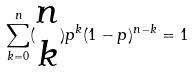<formula> <loc_0><loc_0><loc_500><loc_500>\sum _ { k = 0 } ^ { n } ( \begin{matrix} n \\ k \end{matrix} ) p ^ { k } ( 1 - p ) ^ { n - k } = 1</formula> 